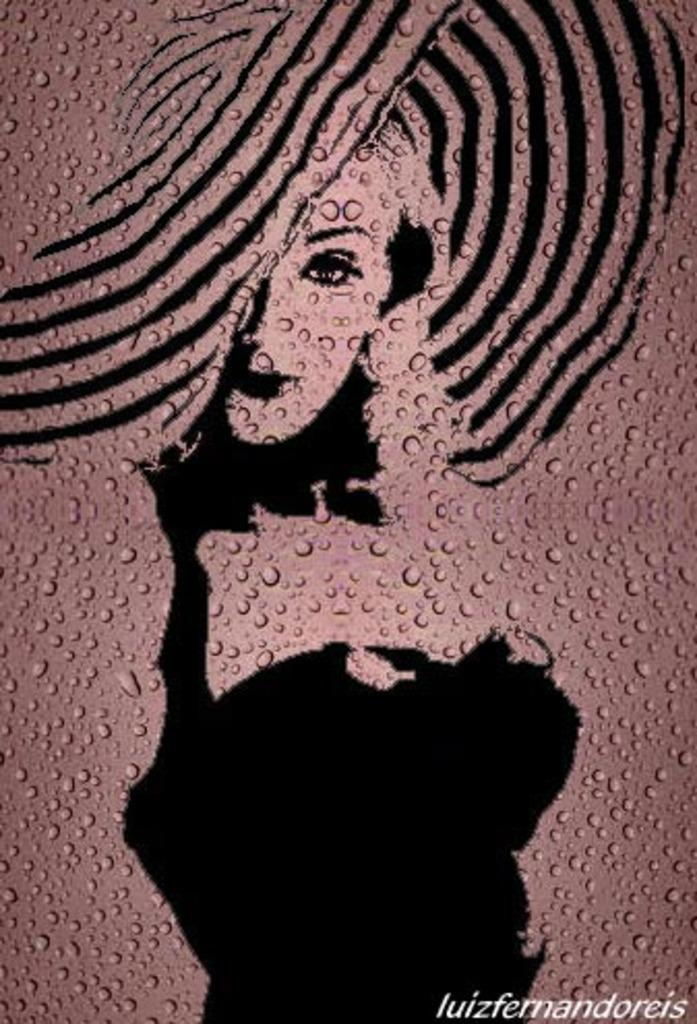What type of image is being shown? The image is an edited picture. What can be seen in the edited picture? There is a painting of a woman in the image. What else is present in the image besides the painting? There are water droplets in the image. Where can you find text in the image? The text is located at the bottom right of the image. How many fingers does the woman in the painting have? The image is a painting of a woman, and it is not possible to determine the number of fingers she has based on the information provided. 